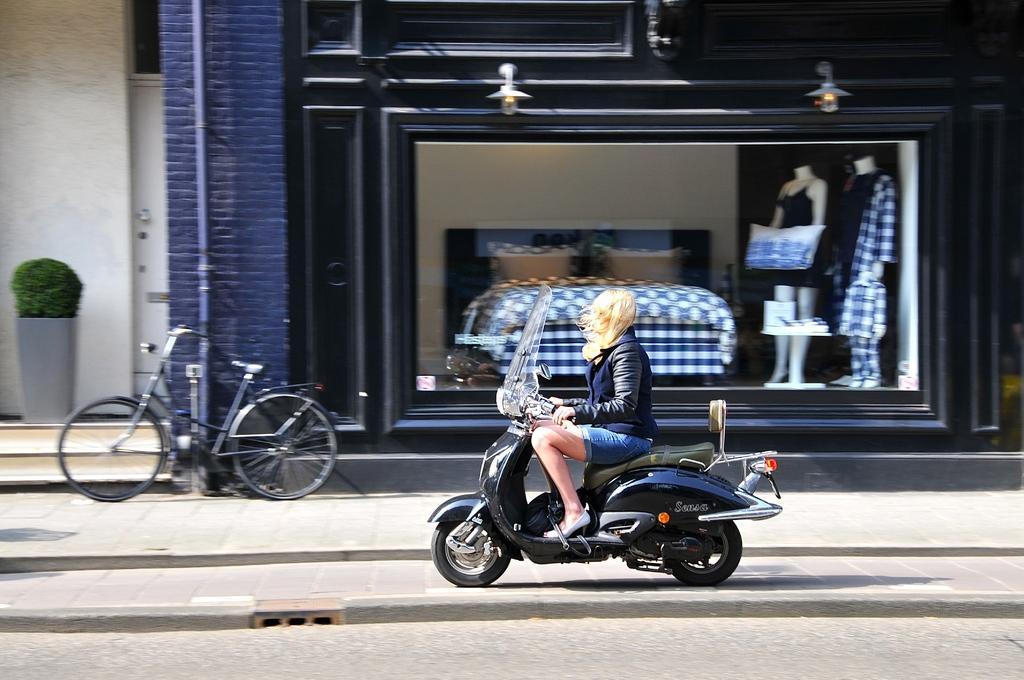Describe this image in one or two sentences. In this image I can see a person is sitting on their bike. In the background I can see a cycle, a plant, two mannequins and a building. 